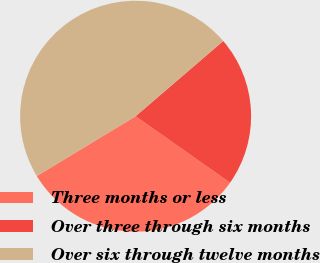Convert chart to OTSL. <chart><loc_0><loc_0><loc_500><loc_500><pie_chart><fcel>Three months or less<fcel>Over three through six months<fcel>Over six through twelve months<nl><fcel>31.58%<fcel>21.05%<fcel>47.37%<nl></chart> 